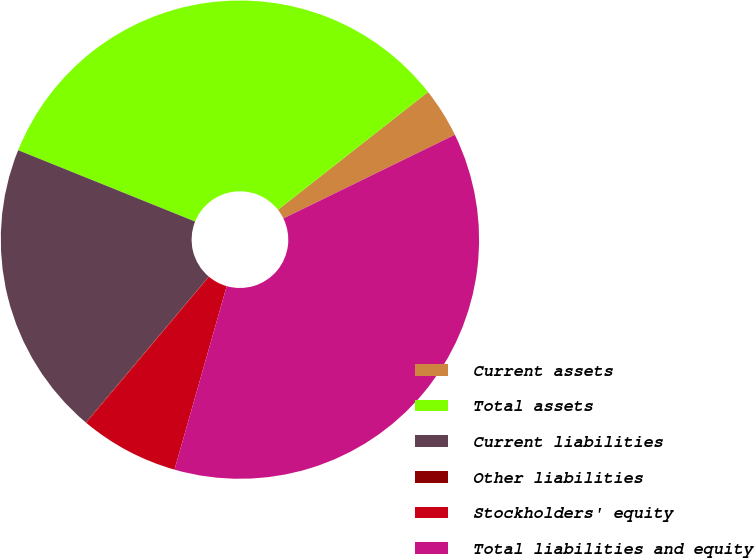Convert chart to OTSL. <chart><loc_0><loc_0><loc_500><loc_500><pie_chart><fcel>Current assets<fcel>Total assets<fcel>Current liabilities<fcel>Other liabilities<fcel>Stockholders' equity<fcel>Total liabilities and equity<nl><fcel>3.37%<fcel>33.31%<fcel>19.94%<fcel>0.05%<fcel>6.7%<fcel>36.64%<nl></chart> 